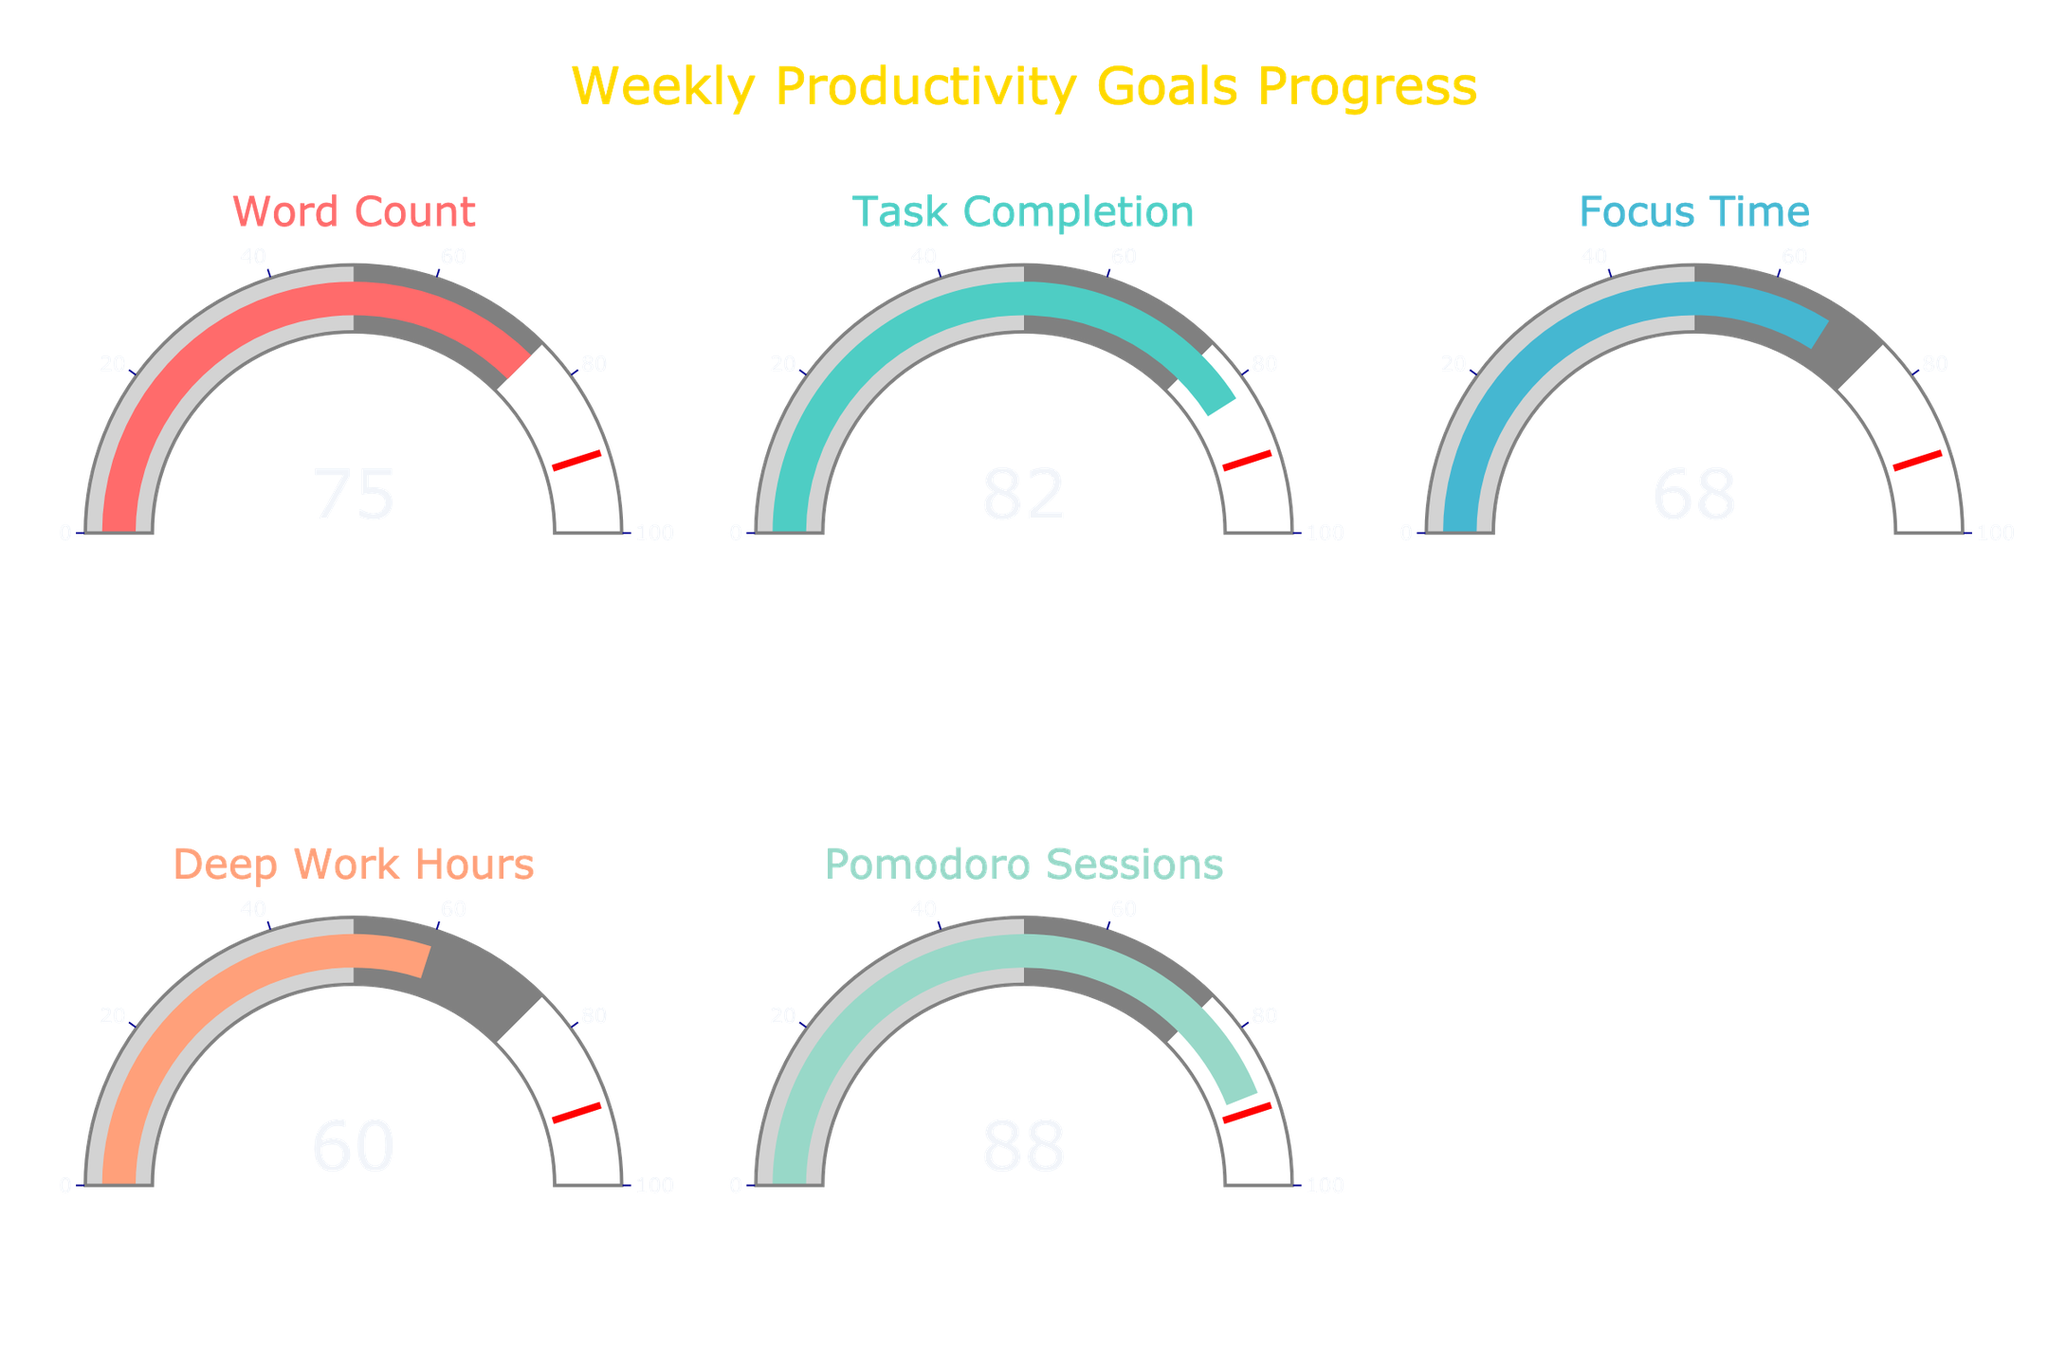What is the progress percentage for Word Count? The value displayed on the gauge for Word Count is 75.
Answer: 75 Which goal has the highest progress percentage? By comparing the values displayed on all gauges, Pomodoro Sessions has the highest progress percentage with a value of 88.
Answer: Pomodoro Sessions How many goals have a progress percentage above 80? The values for Task Completion (82) and Pomodoro Sessions (88) are both above 80. Thus, there are 2 goals with progress percentages above 80.
Answer: 2 What is the average progress percentage for all goals? Sum all the percentages: 75 (Word Count) + 82 (Task Completion) + 68 (Focus Time) + 60 (Deep Work Hours) + 88 (Pomodoro Sessions) = 373. Divide by the number of goals (5), the average is 373 / 5 = 74.6.
Answer: 74.6 Which goals have a progress percentage below 70? The values displayed that are below 70 are Focus Time (68) and Deep Work Hours (60).
Answer: Focus Time and Deep Work Hours What is the difference in progress percentage between Task Completion and Deep Work Hours? Task Completion has a progress percentage of 82, and Deep Work Hours has a percentage of 60. The difference is 82 - 60 = 22.
Answer: 22 How far is Word Count from reaching the 90% threshold? The gauge for Word Count shows a progress percentage of 75. The threshold is 90. The distance to the threshold is 90 - 75 = 15.
Answer: 15 What is the median value of all the progress percentages? The progress percentages are 75, 82, 68, 60, and 88. When arranged in ascending order: 60, 68, 75, 82, and 88. The median, being the middle value, is 75.
Answer: 75 Is Focus Time above or below the average progress percentage of all goals? The average progress percentage calculated for all goals is 74.6. Focus Time has a progress percentage of 68, which is below the average.
Answer: Below Which goal is closest to reaching 75% progress? The values close to 75% are Word Count (75) and Focus Time (68). Since 75 is exactly 75%, Word Count is the closest.
Answer: Word Count 